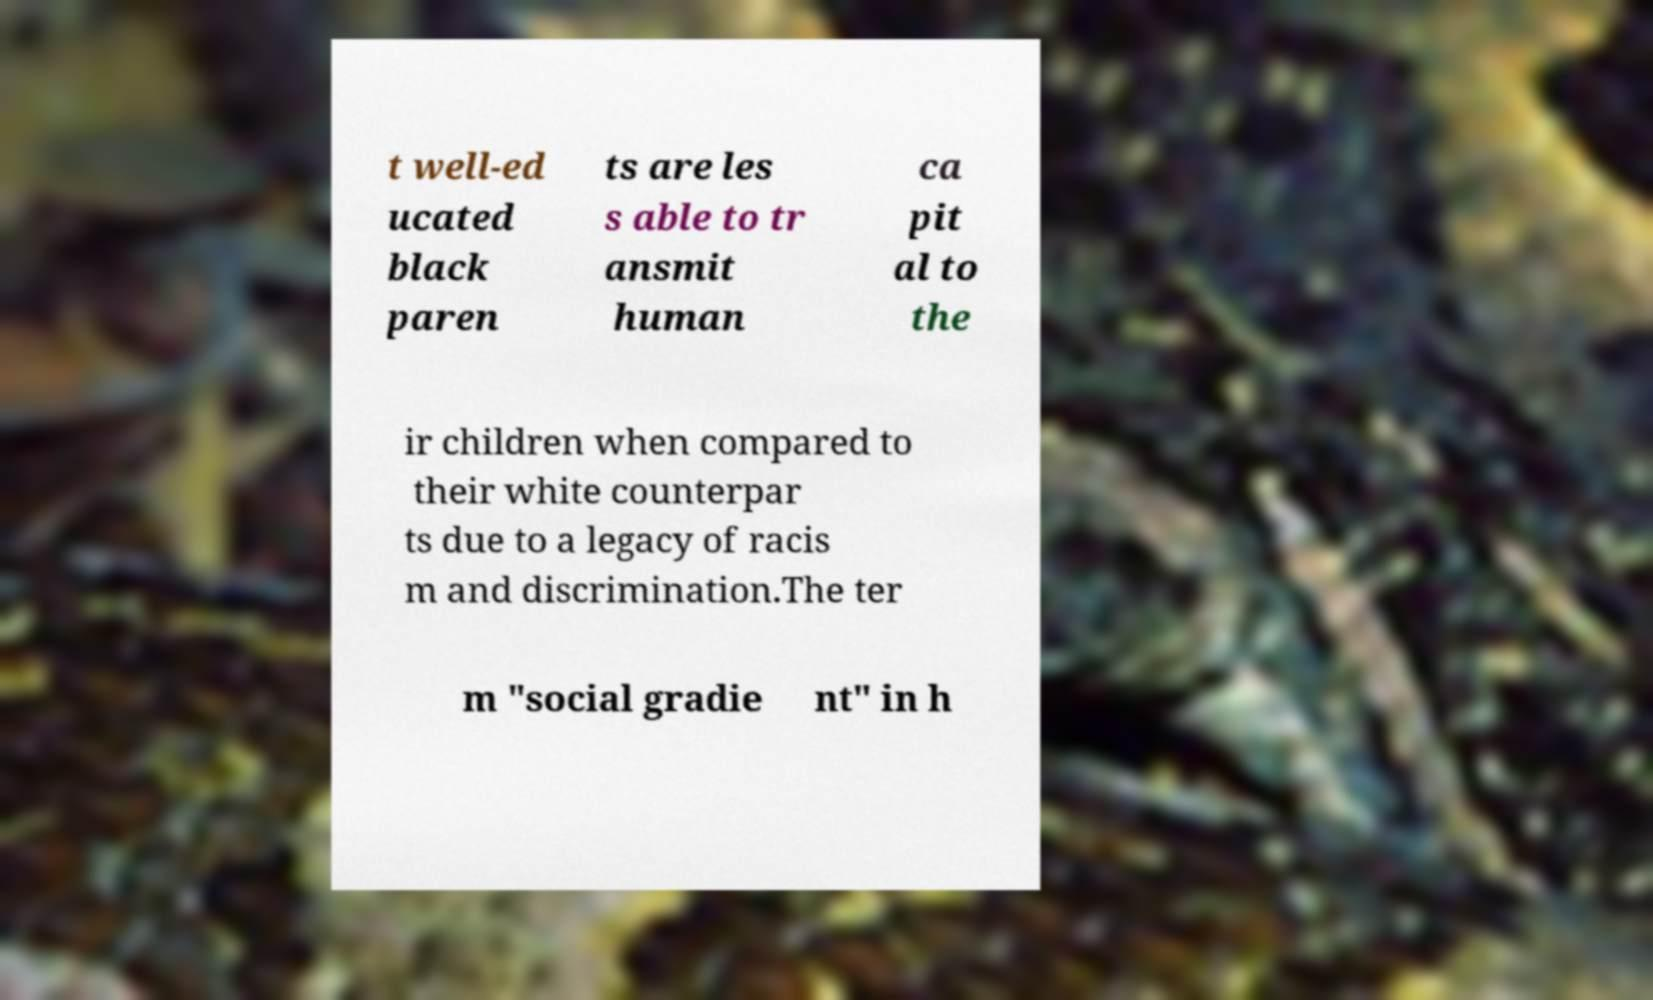Can you read and provide the text displayed in the image?This photo seems to have some interesting text. Can you extract and type it out for me? t well-ed ucated black paren ts are les s able to tr ansmit human ca pit al to the ir children when compared to their white counterpar ts due to a legacy of racis m and discrimination.The ter m "social gradie nt" in h 